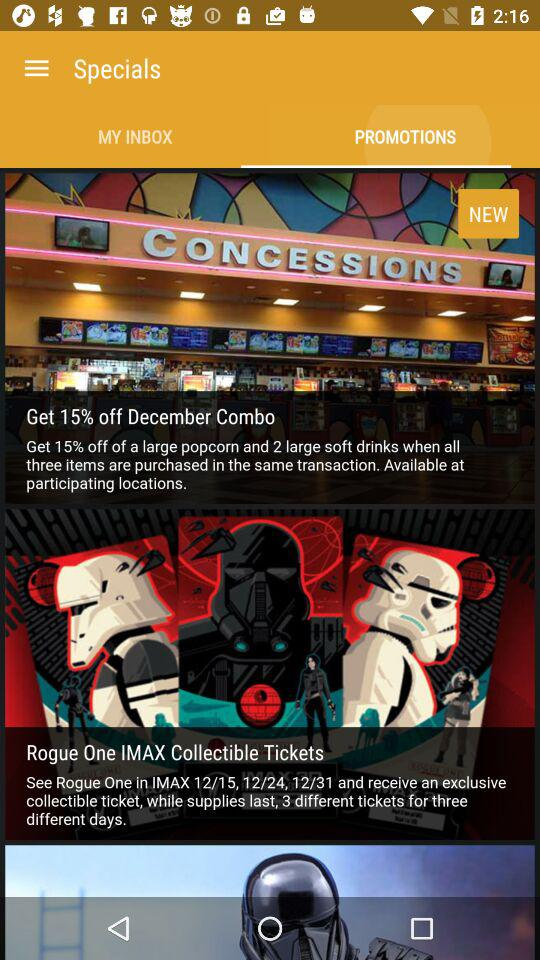For how many days are three different tickets available? Three different tickets are available for three days. 